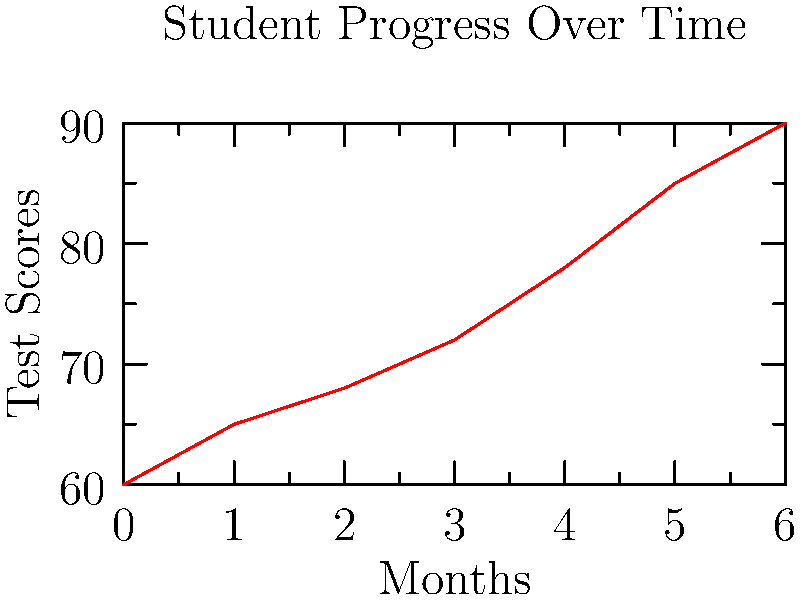Analyze the line graph showing a student's test scores over a 6-month period. If the trend continues, what would be the student's projected score at the 9-month mark? How might you use this information to encourage perseverance in your elementary school students? 1. Observe the trend: The line graph shows a consistent upward trend in the student's test scores over time.

2. Calculate the rate of change:
   - Initial score (month 0): 60
   - Final score (month 6): 90
   - Total increase: 90 - 60 = 30 points
   - Rate of change: 30 points / 6 months = 5 points per month

3. Extend the trend:
   - From month 6 to month 9: 3 additional months
   - Projected increase: 3 months × 5 points/month = 15 points
   - Projected score at month 9: 90 + 15 = 105 points

4. Interpreting for elementary students:
   - Highlight the consistent improvement over time
   - Emphasize that progress takes time and effort
   - Show how small, consistent gains lead to significant improvement
   - Discuss how perseverance led to this student's success
   - Encourage students to set goals and track their own progress

5. Classroom application:
   - Create individual progress charts for students
   - Celebrate improvements, no matter how small
   - Discuss strategies for overcoming challenges and maintaining motivation
Answer: 105 points; use as example of consistent effort leading to significant improvement 